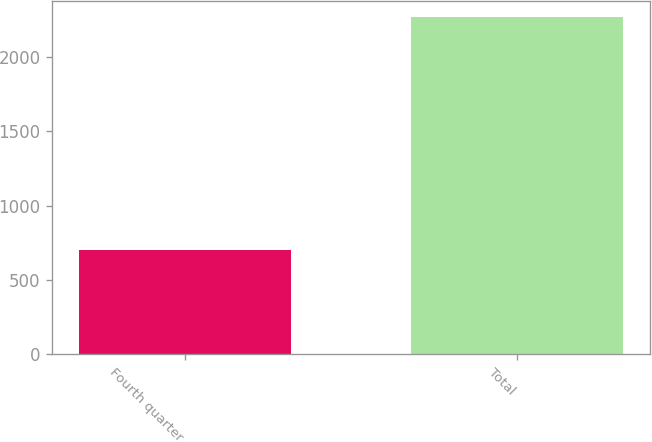Convert chart to OTSL. <chart><loc_0><loc_0><loc_500><loc_500><bar_chart><fcel>Fourth quarter<fcel>Total<nl><fcel>700<fcel>2268<nl></chart> 